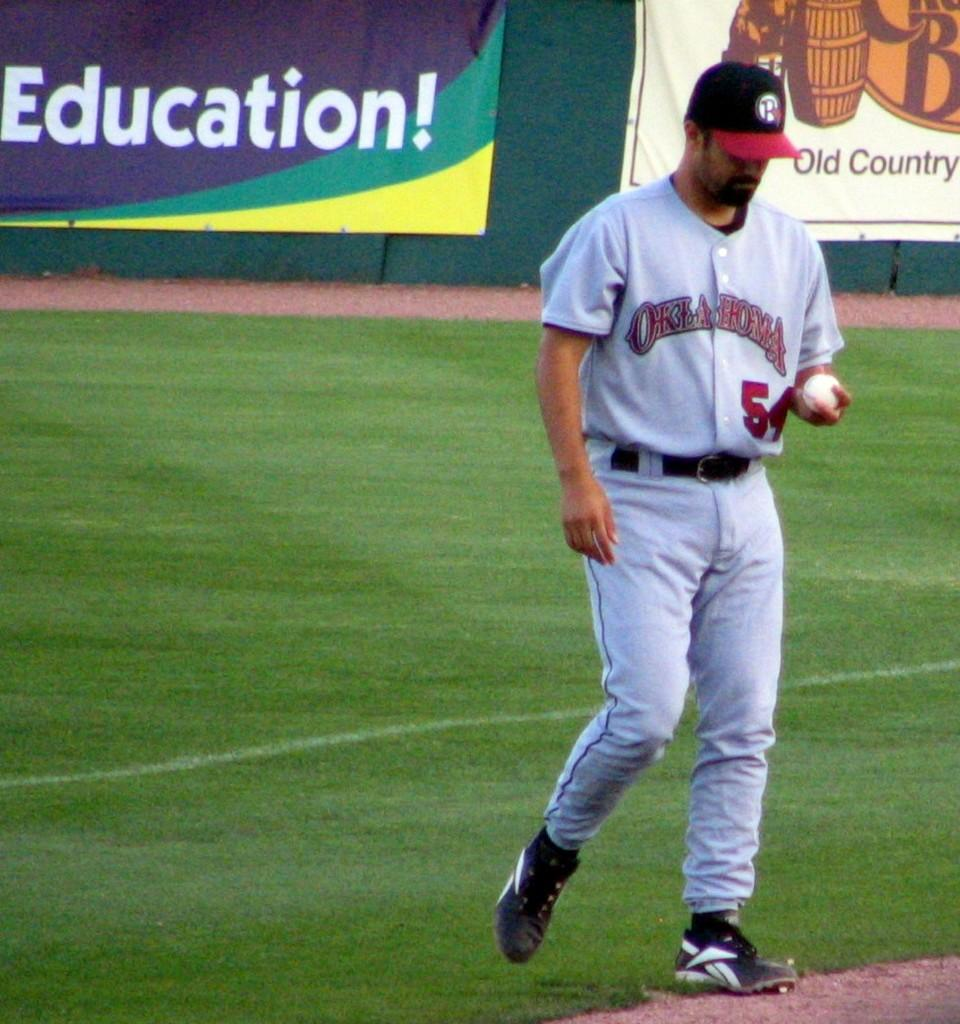Provide a one-sentence caption for the provided image. Player number 54 for Oklahoma holds a baseball during a game. 